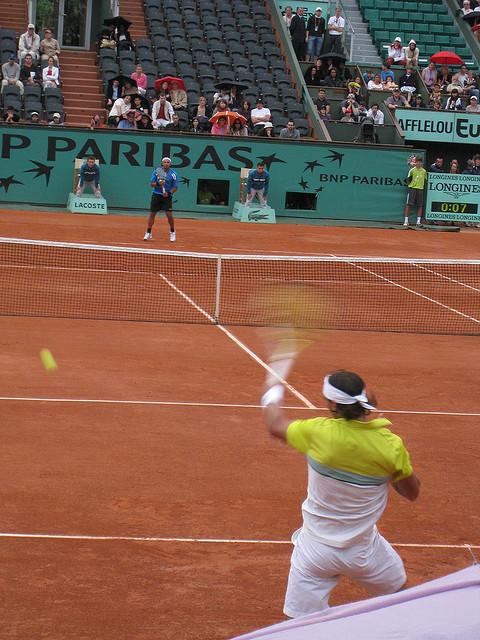What sport are they playing?
Be succinct. Tennis. What color is the tennis player's pants?
Short answer required. White. Is this the French Open at Roland Garros?
Short answer required. Yes. 